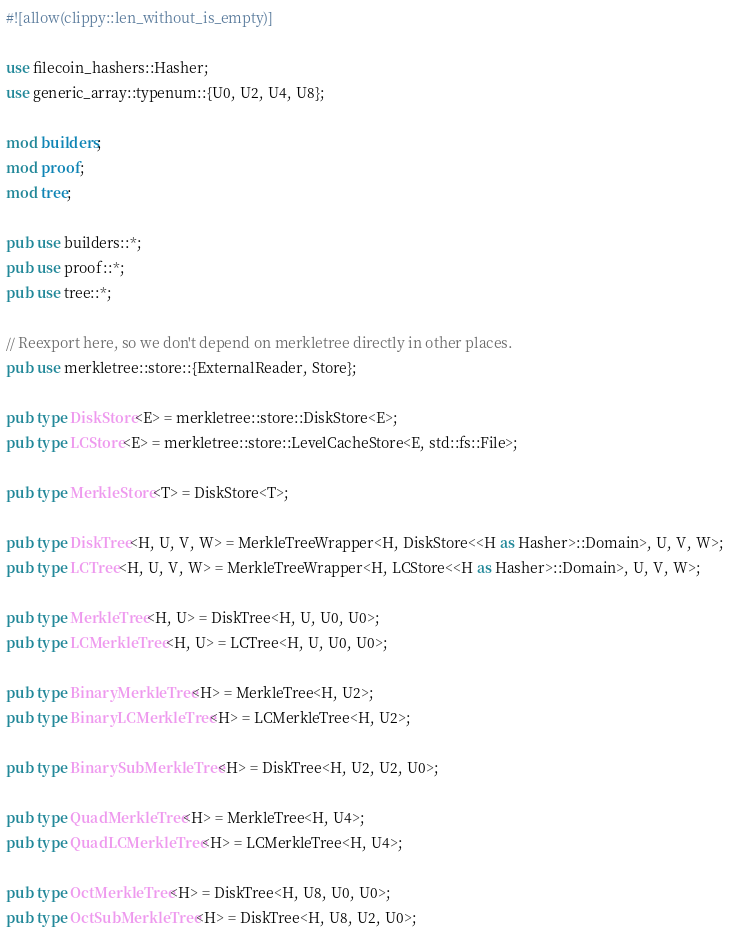Convert code to text. <code><loc_0><loc_0><loc_500><loc_500><_Rust_>#![allow(clippy::len_without_is_empty)]

use filecoin_hashers::Hasher;
use generic_array::typenum::{U0, U2, U4, U8};

mod builders;
mod proof;
mod tree;

pub use builders::*;
pub use proof::*;
pub use tree::*;

// Reexport here, so we don't depend on merkletree directly in other places.
pub use merkletree::store::{ExternalReader, Store};

pub type DiskStore<E> = merkletree::store::DiskStore<E>;
pub type LCStore<E> = merkletree::store::LevelCacheStore<E, std::fs::File>;

pub type MerkleStore<T> = DiskStore<T>;

pub type DiskTree<H, U, V, W> = MerkleTreeWrapper<H, DiskStore<<H as Hasher>::Domain>, U, V, W>;
pub type LCTree<H, U, V, W> = MerkleTreeWrapper<H, LCStore<<H as Hasher>::Domain>, U, V, W>;

pub type MerkleTree<H, U> = DiskTree<H, U, U0, U0>;
pub type LCMerkleTree<H, U> = LCTree<H, U, U0, U0>;

pub type BinaryMerkleTree<H> = MerkleTree<H, U2>;
pub type BinaryLCMerkleTree<H> = LCMerkleTree<H, U2>;

pub type BinarySubMerkleTree<H> = DiskTree<H, U2, U2, U0>;

pub type QuadMerkleTree<H> = MerkleTree<H, U4>;
pub type QuadLCMerkleTree<H> = LCMerkleTree<H, U4>;

pub type OctMerkleTree<H> = DiskTree<H, U8, U0, U0>;
pub type OctSubMerkleTree<H> = DiskTree<H, U8, U2, U0>;</code> 